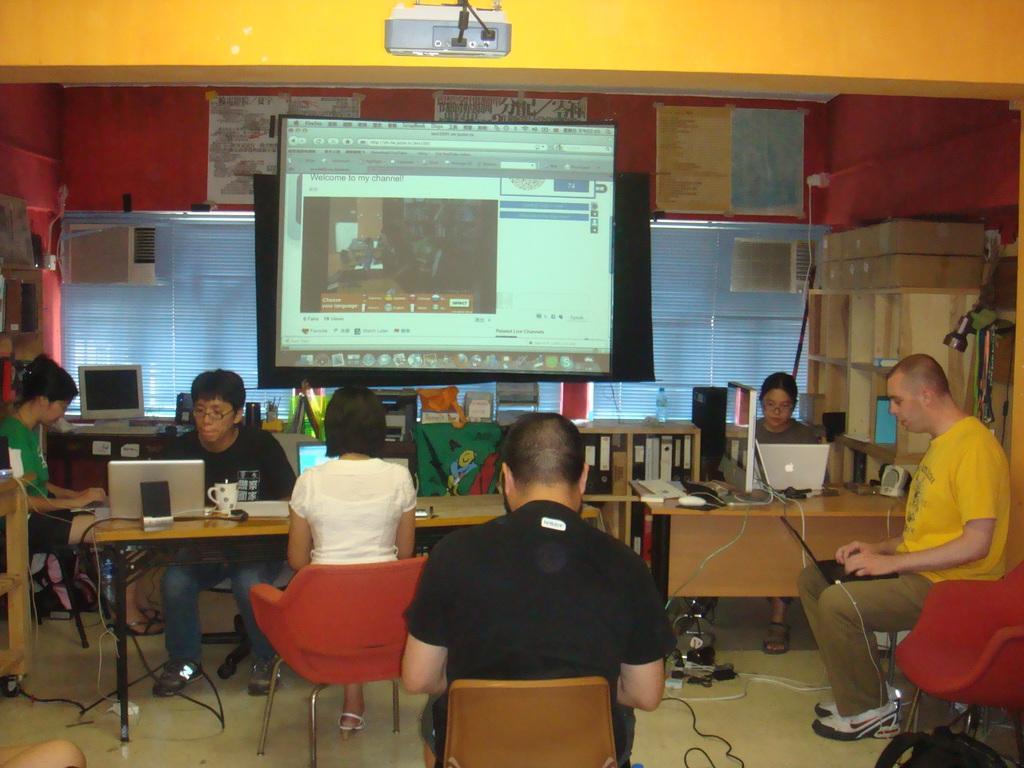Can you describe this image briefly? In this picture there are several people sitting on the table and operating their laptops , in the background we observe a black screen on top of which a projector is displaying the information. There is also few posters attached to the wall , we observe a glass window with a movable curtain. 